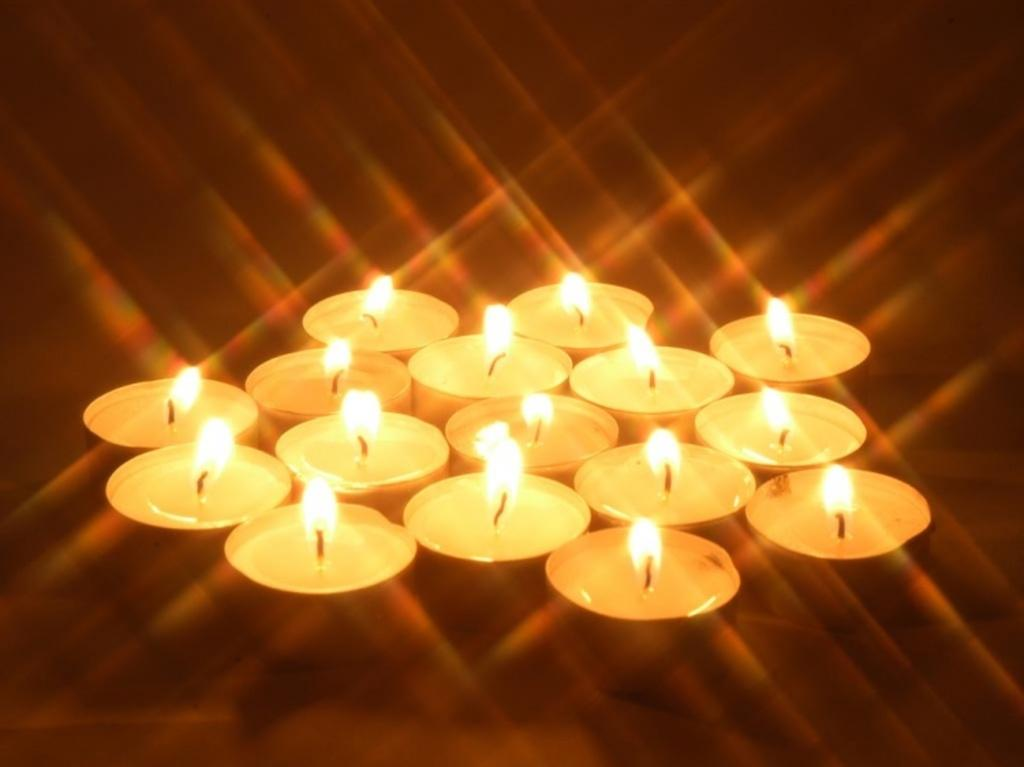What type of candles are present in the image? There are tea light candles in the image. What is the state of the tea light candles in the image? The tea light candles have flames. What type of cord is used to light the tea light candles in the image? There is no mention of a cord in the image, and the tea light candles are already lit with flames. 